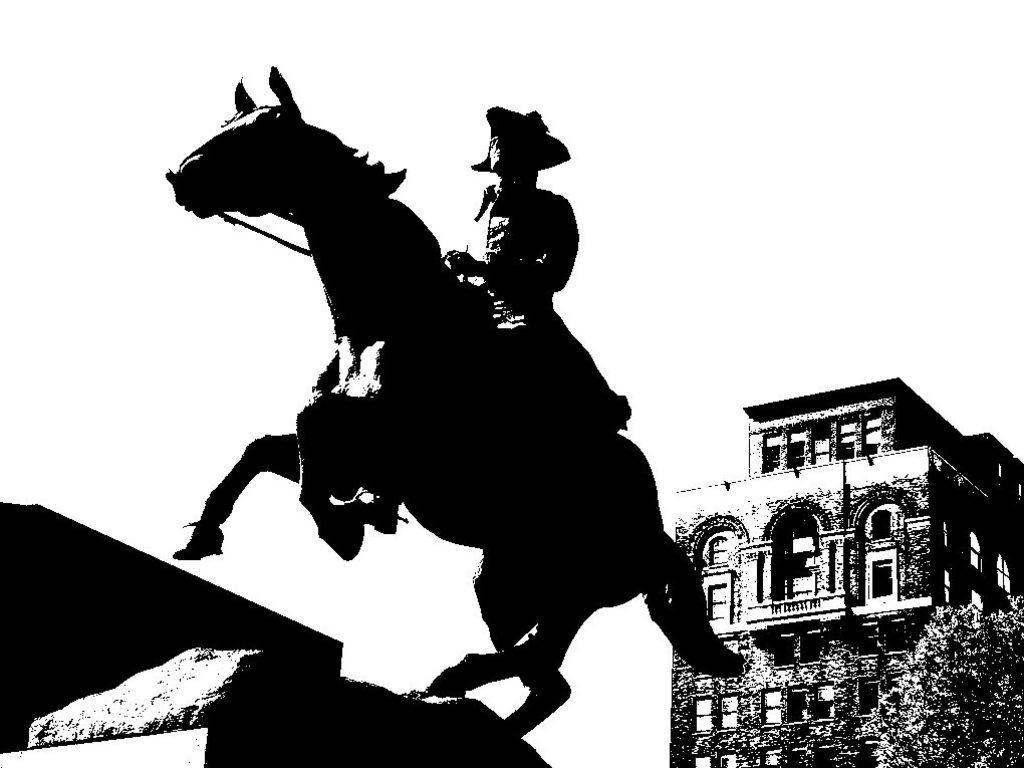What is the color scheme of the image? The image is monochrome. What activity is the person in the image engaged in? The person is riding a horse in the image. What structure can be seen behind the person? There is a building behind the person in the image. What type of vegetation is present in the image? There are plants in the image. How many books can be seen on the horse in the image? There are no books present in the image; it features a person riding a horse with a building and plants in the background. Is there a carriage visible in the image? There is no carriage present in the image. 